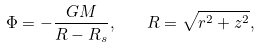Convert formula to latex. <formula><loc_0><loc_0><loc_500><loc_500>\Phi = - \frac { G M } { R - R _ { s } } , \quad R = \sqrt { r ^ { 2 } + z ^ { 2 } } ,</formula> 